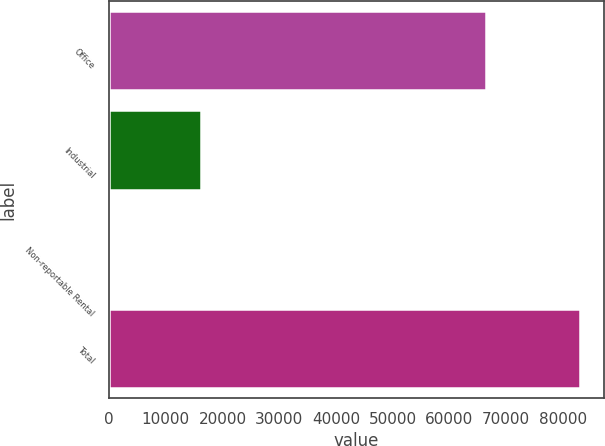<chart> <loc_0><loc_0><loc_500><loc_500><bar_chart><fcel>Office<fcel>Industrial<fcel>Non-reportable Rental<fcel>Total<nl><fcel>66449<fcel>16210<fcel>341<fcel>83000<nl></chart> 